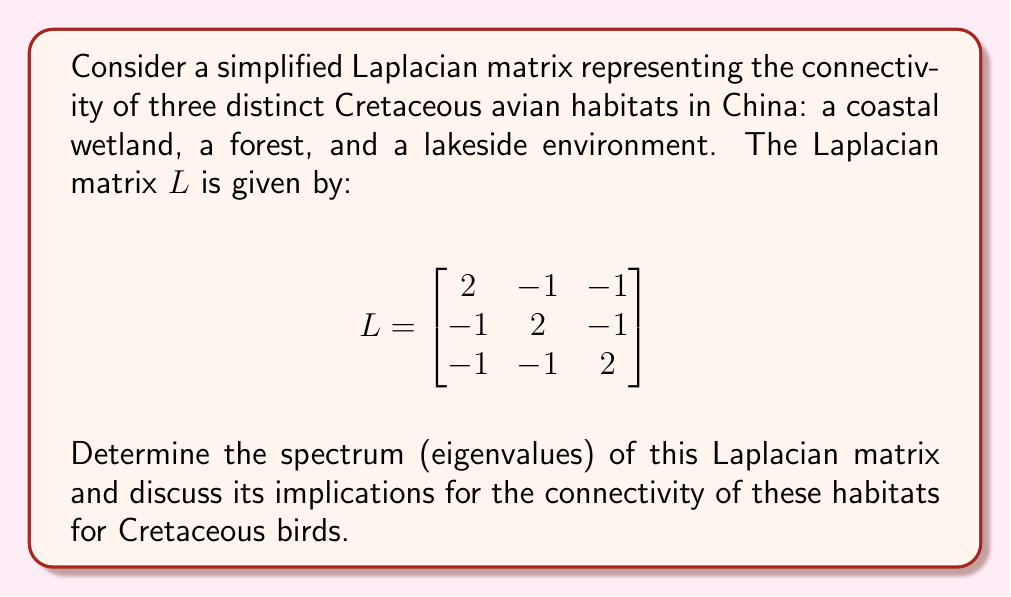Can you answer this question? To find the spectrum of the Laplacian matrix, we need to solve the characteristic equation:

1) First, we set up the equation $\det(L - \lambda I) = 0$, where $I$ is the 3x3 identity matrix:

   $$\det\begin{bmatrix}
   2-\lambda & -1 & -1 \\
   -1 & 2-\lambda & -1 \\
   -1 & -1 & 2-\lambda
   \end{bmatrix} = 0$$

2) Expanding the determinant:
   
   $(2-\lambda)^3 - 3(2-\lambda) + 2 = 0$

3) Simplifying:
   
   $\lambda^3 - 6\lambda^2 + 12\lambda - 8 + 6\lambda - 12 + 2 = 0$
   $\lambda^3 - 6\lambda^2 + 18\lambda - 18 = 0$
   $(\lambda - 3)(\lambda^2 - 3\lambda + 6) = 0$

4) Solving this equation:
   
   $\lambda_1 = 3$
   $\lambda_{2,3} = \frac{3 \pm \sqrt{9-24}}{2} = \frac{3 \pm \sqrt{-15}}{2}$

5) Simplifying the complex roots:
   
   $\lambda_2 = \frac{3 + i\sqrt{15}}{2}$
   $\lambda_3 = \frac{3 - i\sqrt{15}}{2}$

The spectrum of the Laplacian matrix is therefore {3, $\frac{3 + i\sqrt{15}}{2}$, $\frac{3 - i\sqrt{15}}{2}$}.

Implications for Cretaceous bird habitats:
- The largest eigenvalue (3) represents the overall connectivity of the habitat network.
- The presence of a zero eigenvalue (which is not the case here) would indicate disconnected components.
- The multiplicity of the smallest non-zero eigenvalue (known as the algebraic connectivity) is 1, suggesting a well-connected habitat system.
- The complex eigenvalues indicate that the habitat connectivity is not simply hierarchical but involves more intricate relationships between the three environments.
Answer: Spectrum: {3, $\frac{3 + i\sqrt{15}}{2}$, $\frac{3 - i\sqrt{15}}{2}$} 